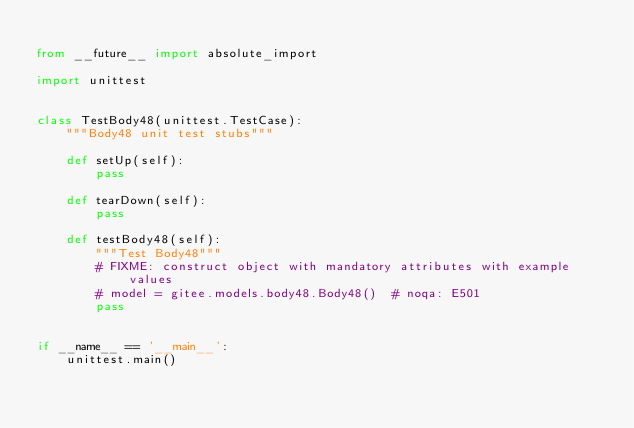Convert code to text. <code><loc_0><loc_0><loc_500><loc_500><_Python_>
from __future__ import absolute_import

import unittest


class TestBody48(unittest.TestCase):
    """Body48 unit test stubs"""

    def setUp(self):
        pass

    def tearDown(self):
        pass

    def testBody48(self):
        """Test Body48"""
        # FIXME: construct object with mandatory attributes with example values
        # model = gitee.models.body48.Body48()  # noqa: E501
        pass


if __name__ == '__main__':
    unittest.main()
</code> 